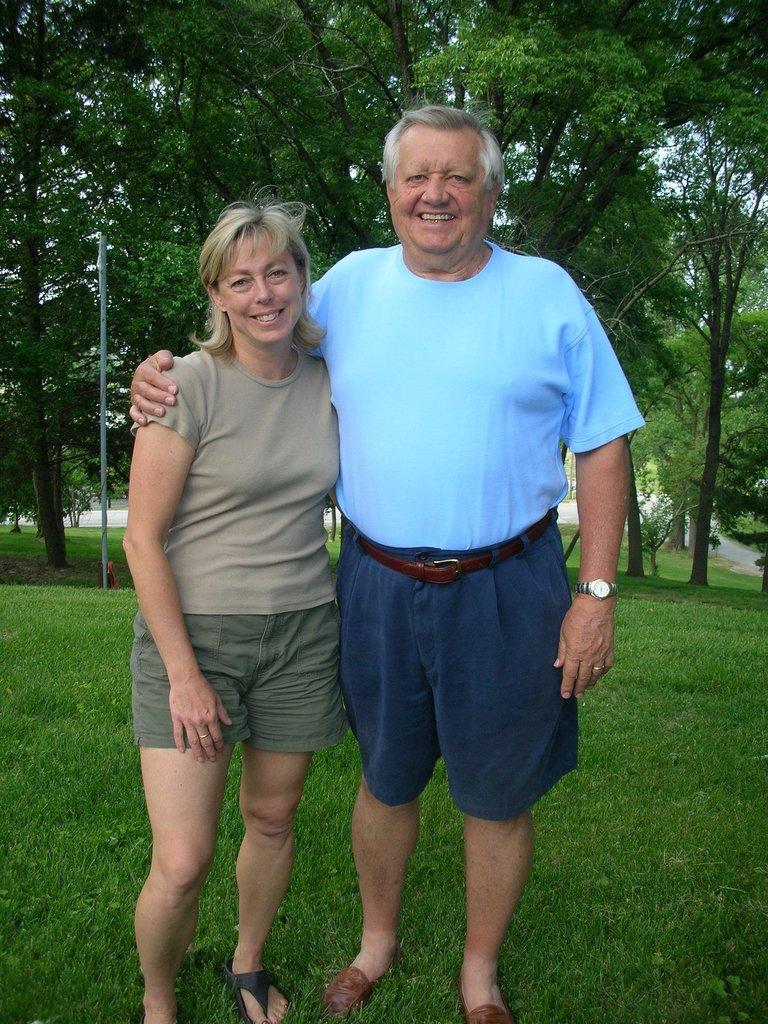Could you give a brief overview of what you see in this image? In this picture we can see a man and a woman standing on the grass and smiling and in the background we can see a pole, path, trees. 